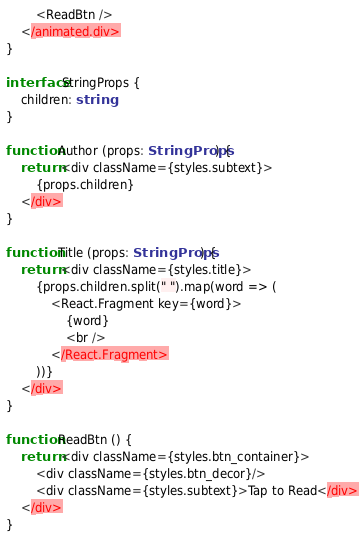Convert code to text. <code><loc_0><loc_0><loc_500><loc_500><_TypeScript_>		<ReadBtn />
	</animated.div>
}

interface StringProps {
	children: string
}

function Author (props: StringProps) {
	return <div className={styles.subtext}>
		{props.children}
	</div>
}

function Title (props: StringProps) {
	return <div className={styles.title}>
		{props.children.split(" ").map(word => (
			<React.Fragment key={word}>
				{word} 
				<br />
			</React.Fragment>
		))}
	</div>
}

function ReadBtn () {
	return <div className={styles.btn_container}>
		<div className={styles.btn_decor}/>
		<div className={styles.subtext}>Tap to Read</div>
	</div>
}</code> 